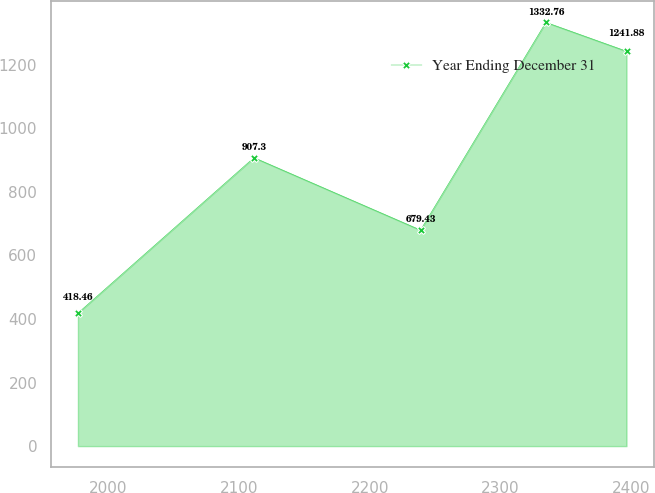Convert chart to OTSL. <chart><loc_0><loc_0><loc_500><loc_500><line_chart><ecel><fcel>Year Ending December 31<nl><fcel>1976.98<fcel>418.46<nl><fcel>2111.53<fcel>907.3<nl><fcel>2238.91<fcel>679.43<nl><fcel>2334.74<fcel>1332.76<nl><fcel>2396.39<fcel>1241.88<nl></chart> 